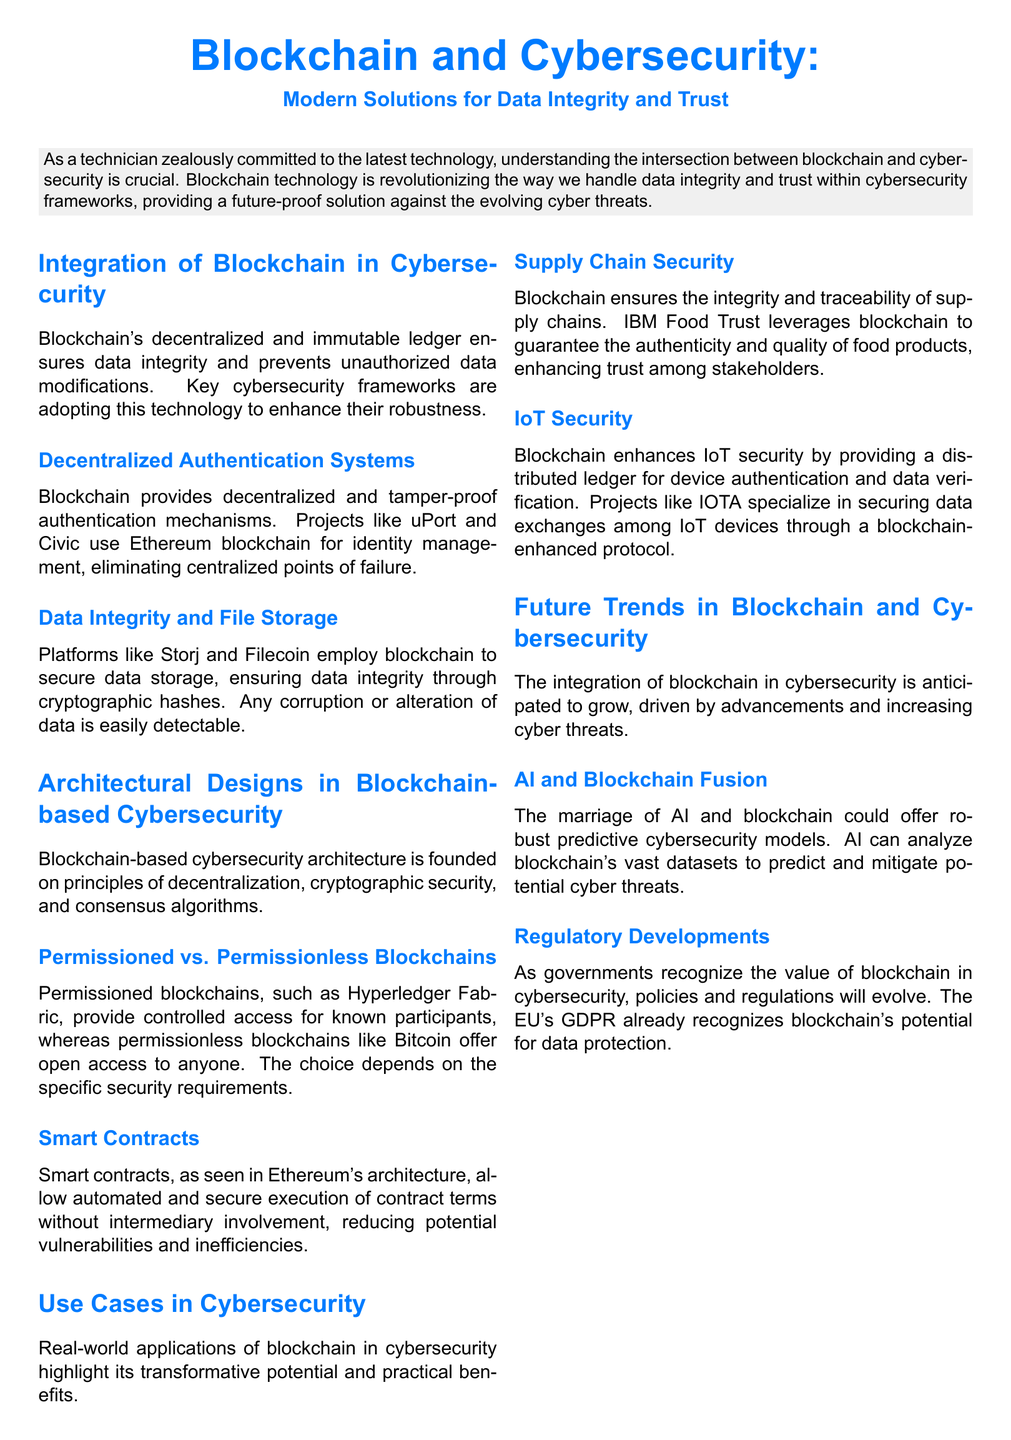What is the title of the whitepaper? The title of the whitepaper is presented at the beginning of the document.
Answer: Blockchain and Cybersecurity: Modern Solutions for Data Integrity and Trust What technology does the whitepaper focus on for enhancing cybersecurity? The whitepaper discusses the integration of blockchain technology in cybersecurity frameworks.
Answer: Blockchain What are two use cases of blockchain in cybersecurity mentioned in the document? The whitepaper lists specific use cases, including Supply Chain Security and IoT Security.
Answer: Supply Chain Security, IoT Security Which blockchain allows automated execution of contract terms? The document highlights that smart contracts enable automated execution within a particular blockchain architecture.
Answer: Ethereum What is the key benefit of decentralized authentication systems? The document notes that decentralized authentication mechanisms prevent centralized points of failure.
Answer: Tamper-proof authentication Name one platform mentioned in the document for secure data storage. The document provides examples of platforms that utilize blockchain for data integrity.
Answer: Storj What future trend does the document suggest regarding AI? The whitepaper identifies a future trend intertwining AI with blockchain for predictive cybersecurity.
Answer: AI and Blockchain Fusion What does the EU's GDPR recognize concerning blockchain? The document mentions that the EU's GDPR acknowledges a specific aspect of blockchain.
Answer: Data protection 